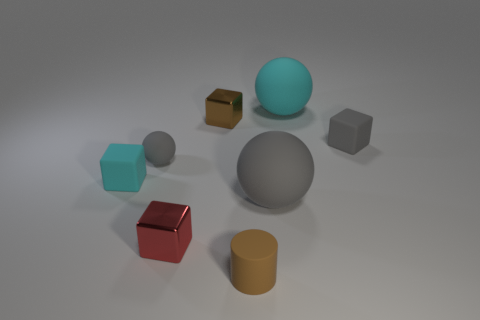Are there the same number of small brown objects that are to the right of the tiny brown rubber object and large things?
Ensure brevity in your answer.  No. There is a matte object that is the same size as the cyan rubber ball; what shape is it?
Give a very brief answer. Sphere. How many other things are there of the same shape as the small brown rubber thing?
Your answer should be compact. 0. Is the size of the red shiny object the same as the cyan object that is right of the large gray object?
Your answer should be very brief. No. How many objects are large rubber balls that are left of the large cyan thing or tiny metal cubes?
Offer a terse response. 3. What shape is the small brown rubber thing that is right of the small gray ball?
Offer a terse response. Cylinder. Are there the same number of tiny rubber cylinders left of the red shiny block and brown things to the left of the matte cylinder?
Offer a very short reply. No. The matte ball that is in front of the cyan rubber ball and right of the tiny cylinder is what color?
Give a very brief answer. Gray. There is a red cube that is in front of the large thing on the right side of the big gray ball; what is its material?
Offer a terse response. Metal. Does the red thing have the same size as the matte cylinder?
Make the answer very short. Yes. 